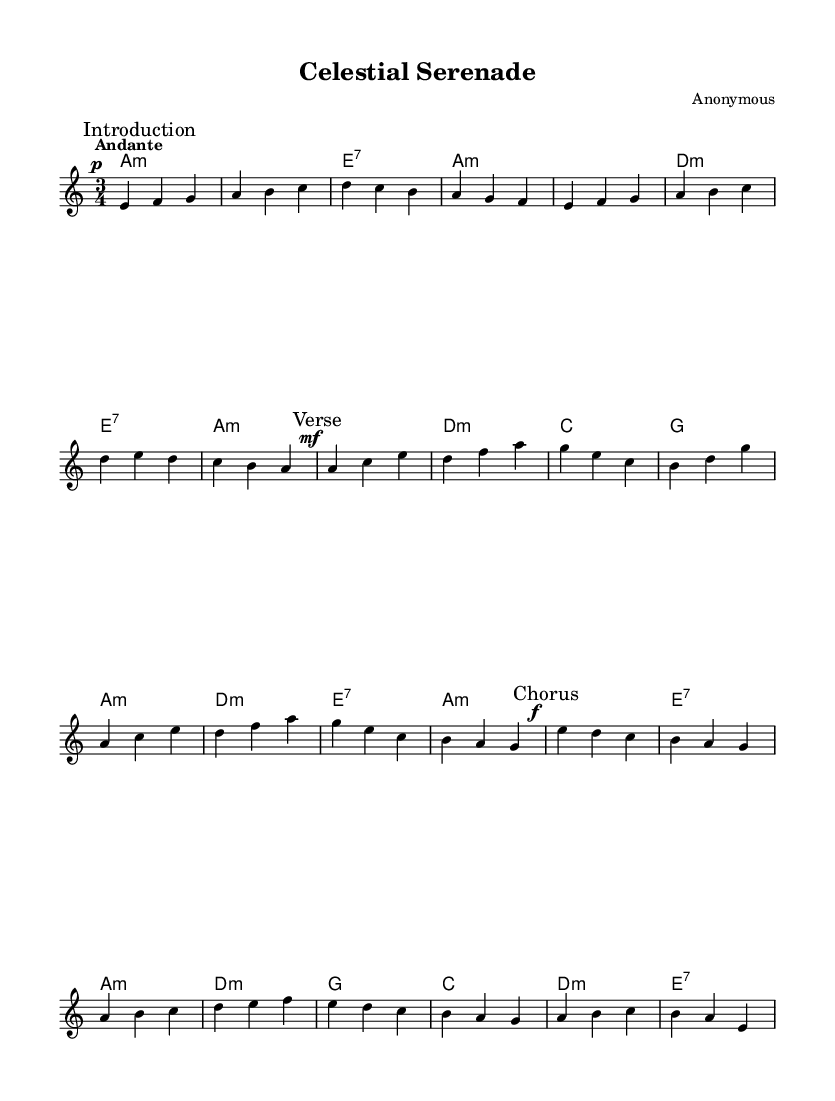What is the key signature of this music? The key signature presented is A minor, indicated by the absence of sharps or flats. This can be inferred from the global settings in the code where it specifies \key a \minor.
Answer: A minor What is the time signature of this music? The time signature is 3/4, as specified in the global settings of the code with \time 3/4. This means there are three beats per measure, and the quarter note receives one beat.
Answer: 3/4 What is the tempo marking for this music? The tempo marking is "Andante," which is indicated in the global settings. This implies that the music should be played at a moderately slow tempo.
Answer: Andante How many measures are in the chorus section? The chorus section contains 8 measures, which can be deduced by counting the distinct sections that are marked with \mark "Chorus" in the code.
Answer: 8 What type of chord does the music start with? The music starts with an A minor chord, stated in the chord progression at the beginning of the piece (a2.:m in the harmonies section).
Answer: A minor Which section contains the highest dynamics? The chorus section contains the highest dynamics, indicated by the use of "f" (forte) at the beginning of its measures, as opposed to "mf" (mezzo-forte) in the verse. This shows that the chorus is meant to be played louder than the verse.
Answer: Chorus What is the last chord played in the piece? The last chord played in the piece is E7, as indicated in the harmonies section where it is the last stated chord in the chorus.
Answer: E7 